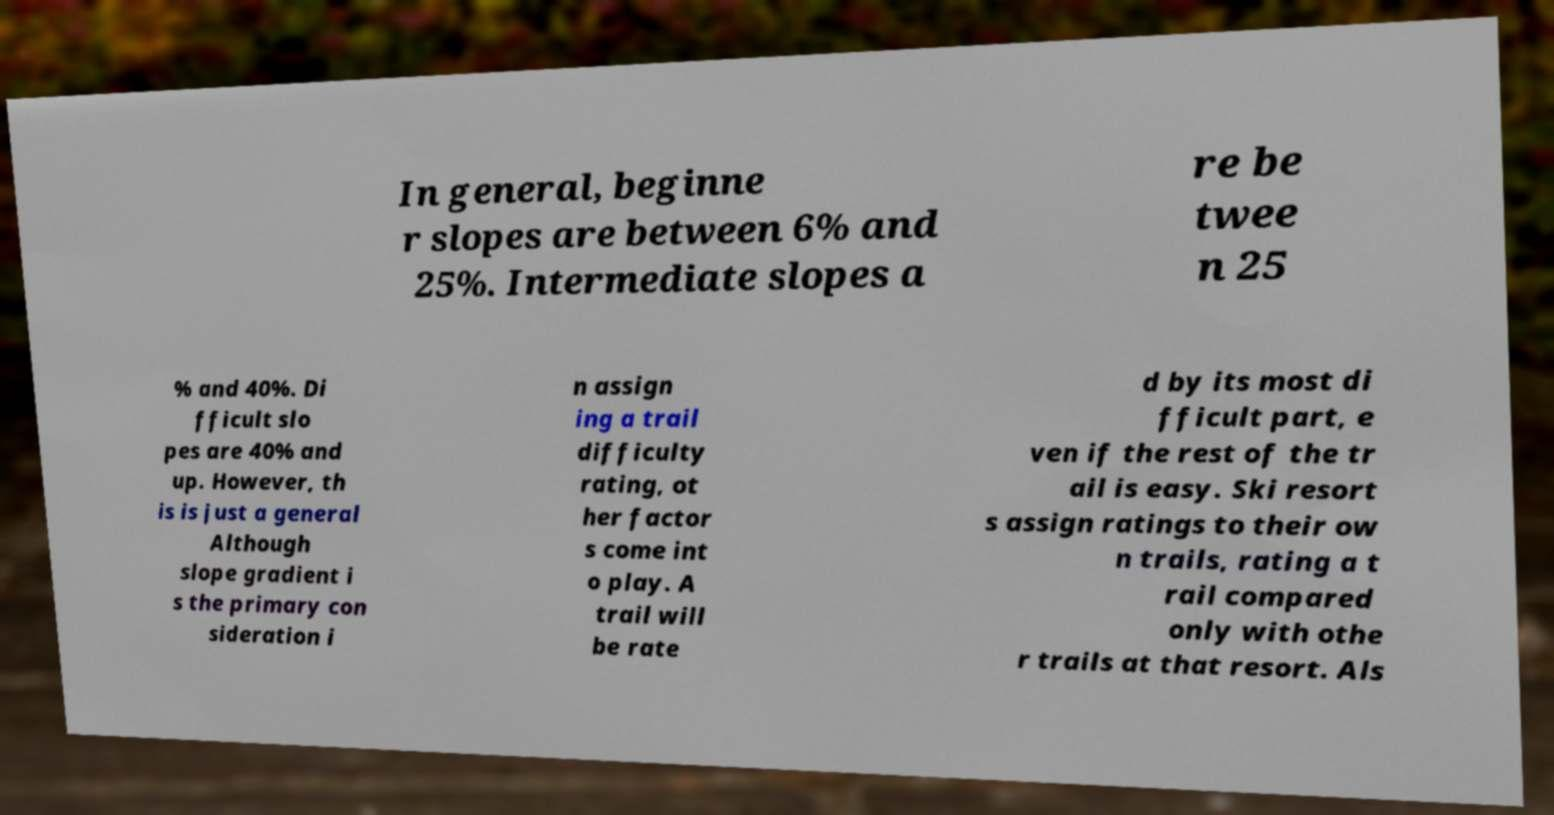Could you extract and type out the text from this image? In general, beginne r slopes are between 6% and 25%. Intermediate slopes a re be twee n 25 % and 40%. Di fficult slo pes are 40% and up. However, th is is just a general Although slope gradient i s the primary con sideration i n assign ing a trail difficulty rating, ot her factor s come int o play. A trail will be rate d by its most di fficult part, e ven if the rest of the tr ail is easy. Ski resort s assign ratings to their ow n trails, rating a t rail compared only with othe r trails at that resort. Als 